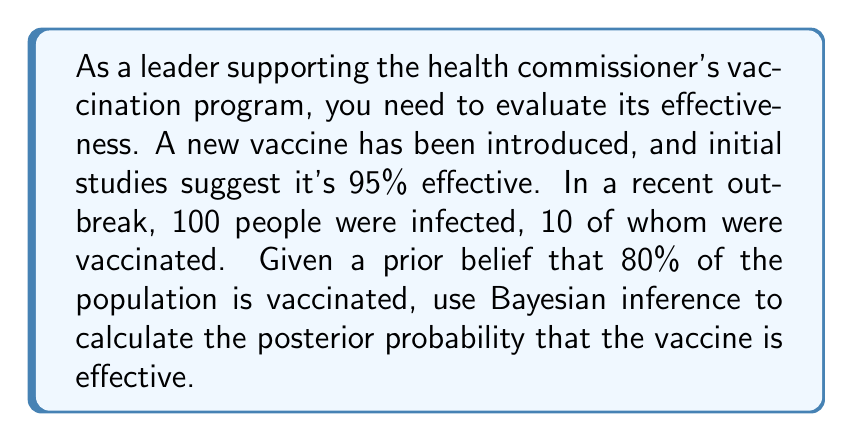Give your solution to this math problem. Let's approach this step-by-step using Bayesian inference:

1) Define our variables:
   E: Event that the vaccine is effective
   D: Data observed (10 vaccinated people infected out of 100 total infections)

2) We need to calculate P(E|D) using Bayes' theorem:

   $$P(E|D) = \frac{P(D|E) \cdot P(E)}{P(D)}$$

3) Given information:
   - Prior probability: P(E) = 0.95 (95% effective from initial studies)
   - 80% of population is vaccinated

4) Calculate P(D|E):
   If the vaccine is effective and 80% are vaccinated, we expect:
   $$P(D|E) = \binom{100}{10} \cdot (0.05 \cdot 0.8)^{10} \cdot (1 - 0.05 \cdot 0.8)^{90}$$
   
   $$= \binom{100}{10} \cdot (0.04)^{10} \cdot (0.96)^{90} \approx 0.0416$$

5) Calculate P(D|not E):
   If the vaccine is not effective, the vaccination status doesn't matter:
   $$P(D|not E) = \binom{100}{10} \cdot (0.8)^{10} \cdot (0.2)^{90} \approx 1.68 \times 10^{-41}$$

6) Calculate P(D):
   $$P(D) = P(D|E) \cdot P(E) + P(D|not E) \cdot P(not E)$$
   $$= 0.0416 \cdot 0.95 + 1.68 \times 10^{-41} \cdot 0.05 \approx 0.0395$$

7) Now we can calculate P(E|D):
   $$P(E|D) = \frac{0.0416 \cdot 0.95}{0.0395} \approx 0.9999$$

Therefore, the posterior probability that the vaccine is effective is approximately 0.9999 or 99.99%.
Answer: 0.9999 